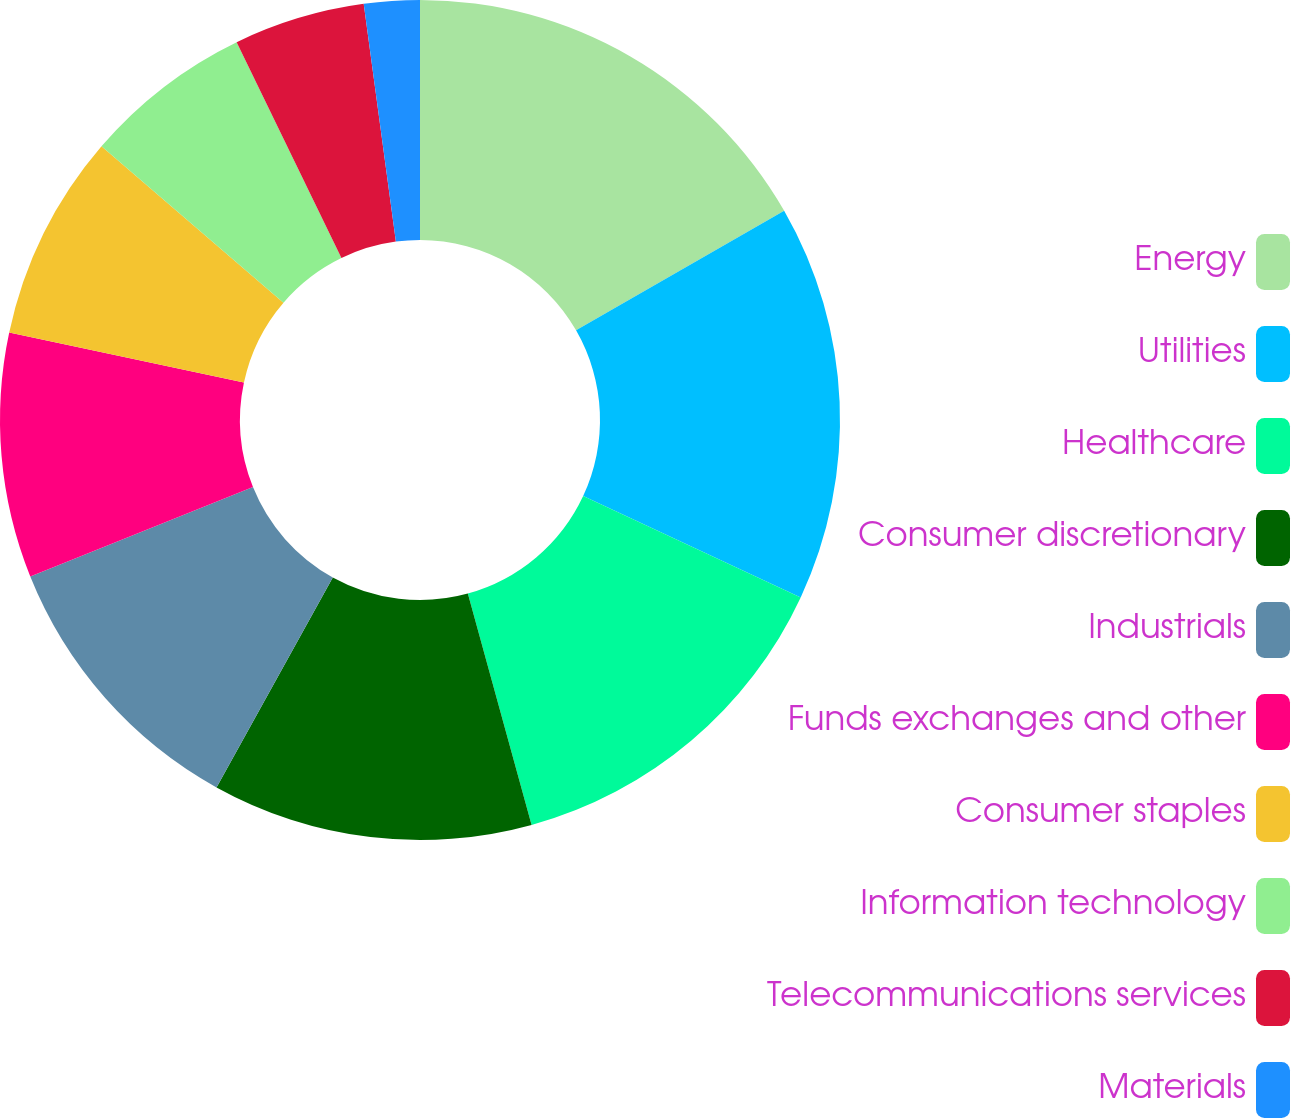<chart> <loc_0><loc_0><loc_500><loc_500><pie_chart><fcel>Energy<fcel>Utilities<fcel>Healthcare<fcel>Consumer discretionary<fcel>Industrials<fcel>Funds exchanges and other<fcel>Consumer staples<fcel>Information technology<fcel>Telecommunications services<fcel>Materials<nl><fcel>16.7%<fcel>15.24%<fcel>13.78%<fcel>12.33%<fcel>10.87%<fcel>9.42%<fcel>7.96%<fcel>6.51%<fcel>5.05%<fcel>2.14%<nl></chart> 